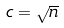Convert formula to latex. <formula><loc_0><loc_0><loc_500><loc_500>c = \sqrt { n }</formula> 